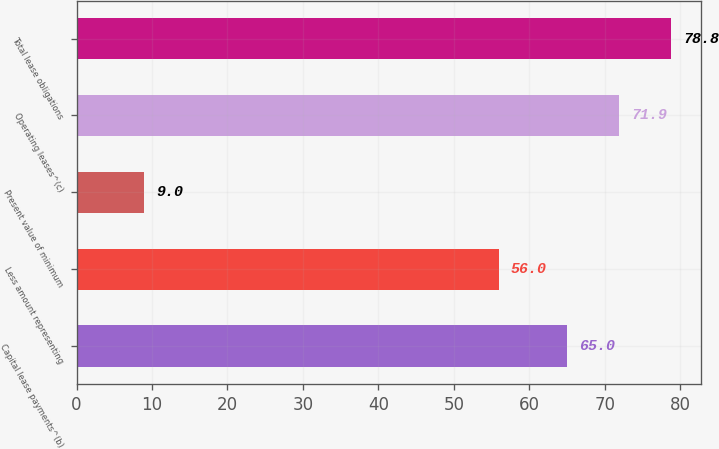<chart> <loc_0><loc_0><loc_500><loc_500><bar_chart><fcel>Capital lease payments^(b)<fcel>Less amount representing<fcel>Present value of minimum<fcel>Operating leases^(c)<fcel>Total lease obligations<nl><fcel>65<fcel>56<fcel>9<fcel>71.9<fcel>78.8<nl></chart> 